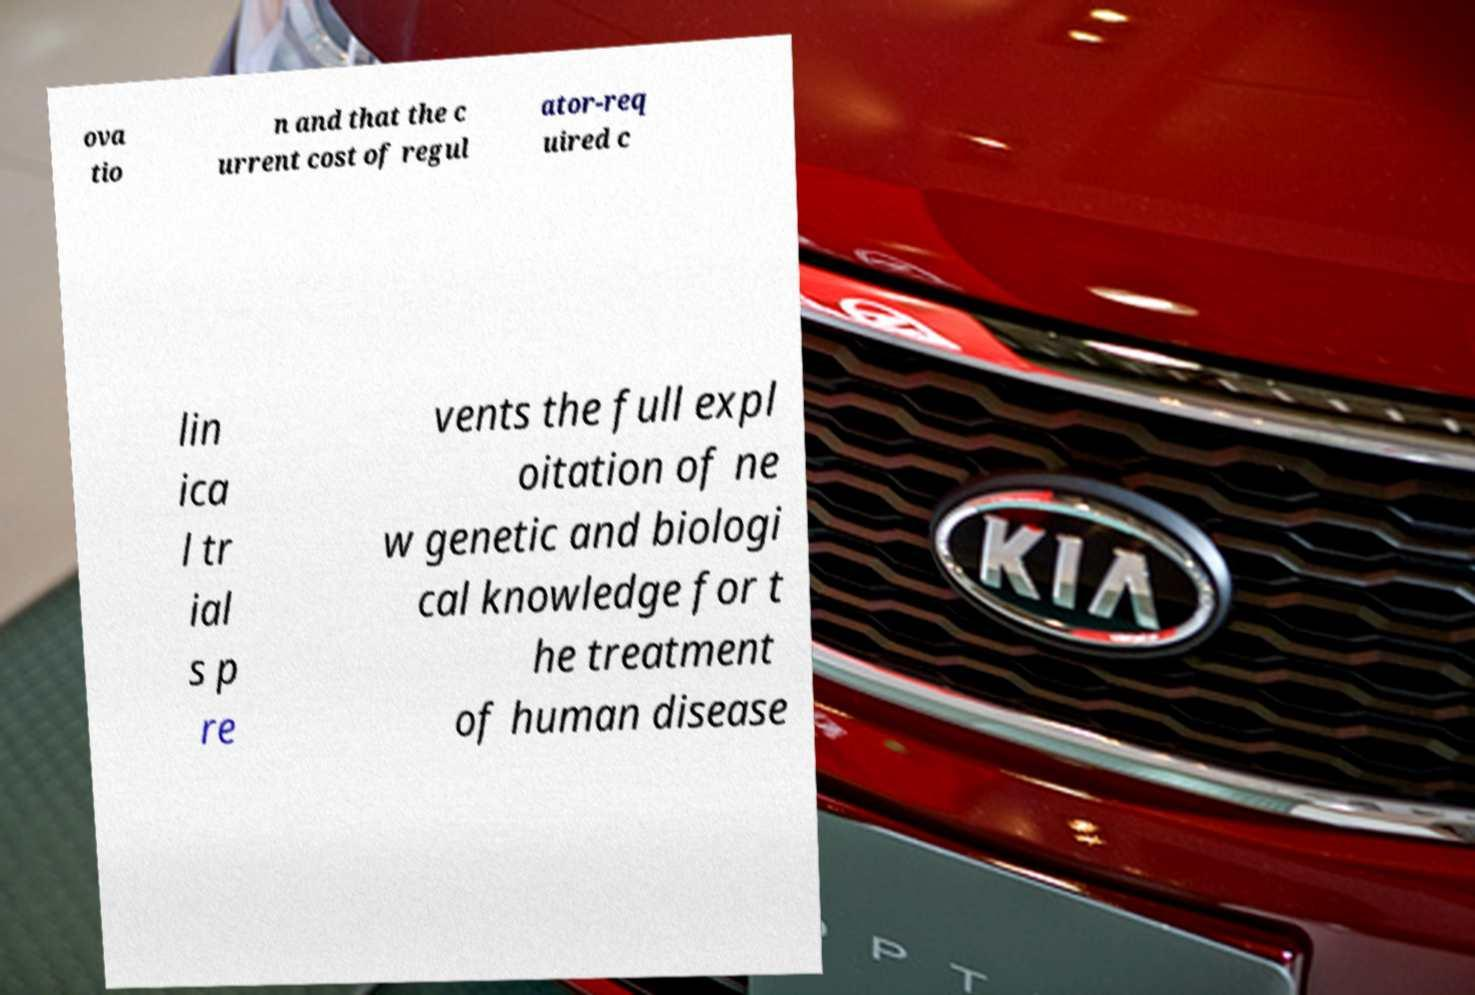Could you extract and type out the text from this image? ova tio n and that the c urrent cost of regul ator-req uired c lin ica l tr ial s p re vents the full expl oitation of ne w genetic and biologi cal knowledge for t he treatment of human disease 